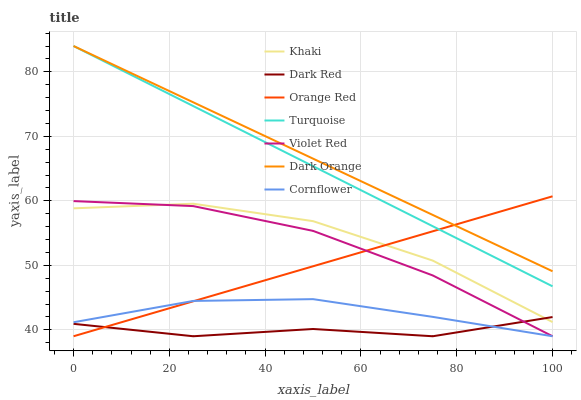Does Dark Red have the minimum area under the curve?
Answer yes or no. Yes. Does Dark Orange have the maximum area under the curve?
Answer yes or no. Yes. Does Turquoise have the minimum area under the curve?
Answer yes or no. No. Does Turquoise have the maximum area under the curve?
Answer yes or no. No. Is Dark Orange the smoothest?
Answer yes or no. Yes. Is Khaki the roughest?
Answer yes or no. Yes. Is Khaki the smoothest?
Answer yes or no. No. Is Turquoise the roughest?
Answer yes or no. No. Does Turquoise have the lowest value?
Answer yes or no. No. Does Turquoise have the highest value?
Answer yes or no. Yes. Does Khaki have the highest value?
Answer yes or no. No. Is Violet Red less than Turquoise?
Answer yes or no. Yes. Is Dark Orange greater than Violet Red?
Answer yes or no. Yes. Does Dark Red intersect Khaki?
Answer yes or no. Yes. Is Dark Red less than Khaki?
Answer yes or no. No. Is Dark Red greater than Khaki?
Answer yes or no. No. Does Violet Red intersect Turquoise?
Answer yes or no. No. 